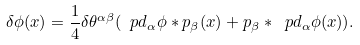<formula> <loc_0><loc_0><loc_500><loc_500>\delta \phi ( x ) = \frac { 1 } { 4 } \delta \theta ^ { \alpha \beta } ( \ p d _ { \alpha } \phi * p _ { \beta } ( x ) + p _ { \beta } * \ p d _ { \alpha } \phi ( x ) ) .</formula> 